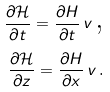Convert formula to latex. <formula><loc_0><loc_0><loc_500><loc_500>\frac { \partial \mathcal { H } } { \partial t } = \frac { \partial H } { \partial t } \, v \, \text {,} \\ \frac { \partial \mathcal { H } } { \partial z } = \frac { \partial H } { \partial x } \, v \, \text {.}</formula> 